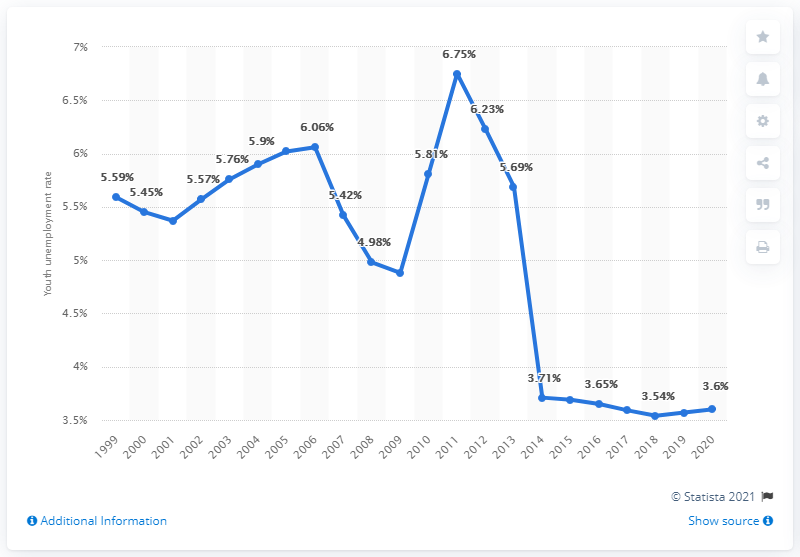Give some essential details in this illustration. The youth unemployment rate in Tanzania was 3.6% in 2020. 